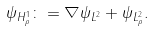<formula> <loc_0><loc_0><loc_500><loc_500>\| \psi \| _ { H ^ { 1 } _ { \rho } } \colon = \| \nabla \psi \| _ { L ^ { 2 } } + \| \psi \| _ { L ^ { 2 } _ { \rho } } .</formula> 